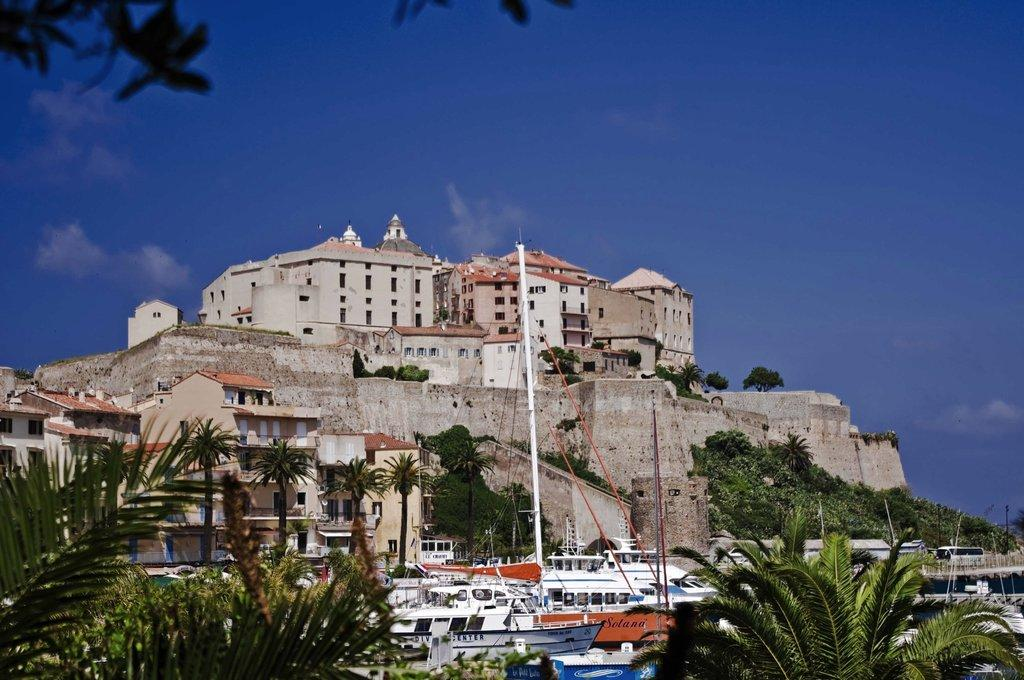What type of structure is visible in the image? There is a building in the image. What is located in the front of the image? There is a wall in the front of the image. What can be seen at the bottom of the image? There are boats and trees at the bottom of the image. What is visible at the top of the image? The sky is visible at the top of the image. Can you see a squirrel climbing the wall in the image? There is no squirrel present in the image. What type of wheel is attached to the boats in the image? There are no wheels visible in the image; the boats are likely floating on water. 